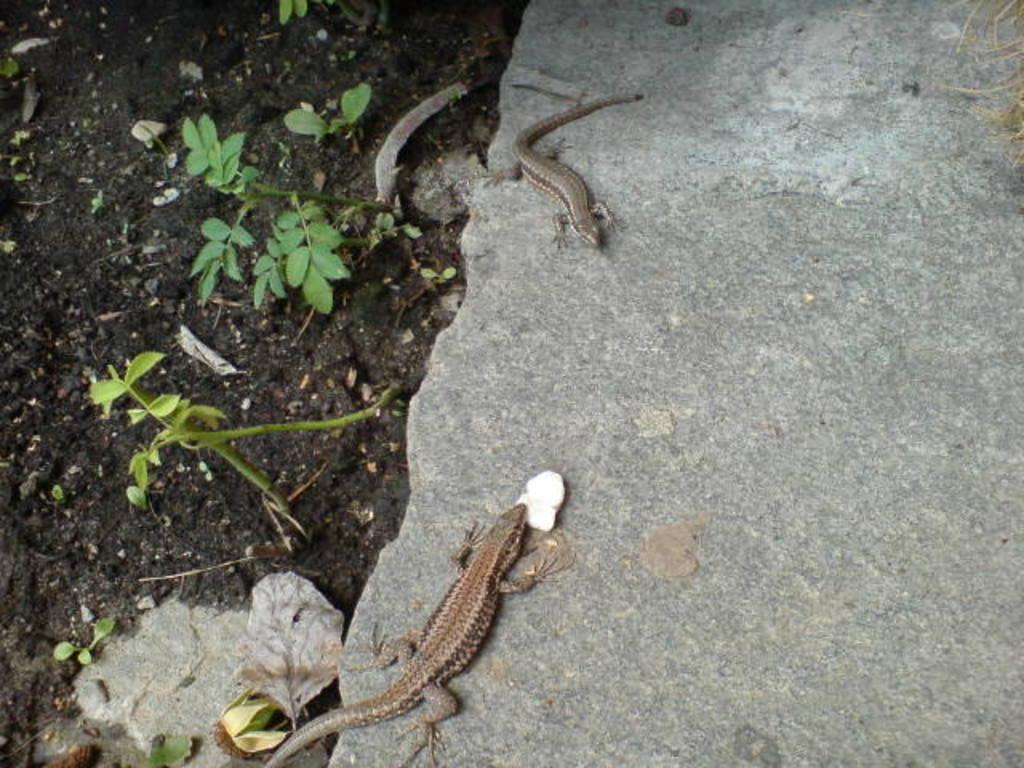Can you describe this image briefly? In this image we can see two lizards are on the surface of the rock and some plants are present on the ground. 